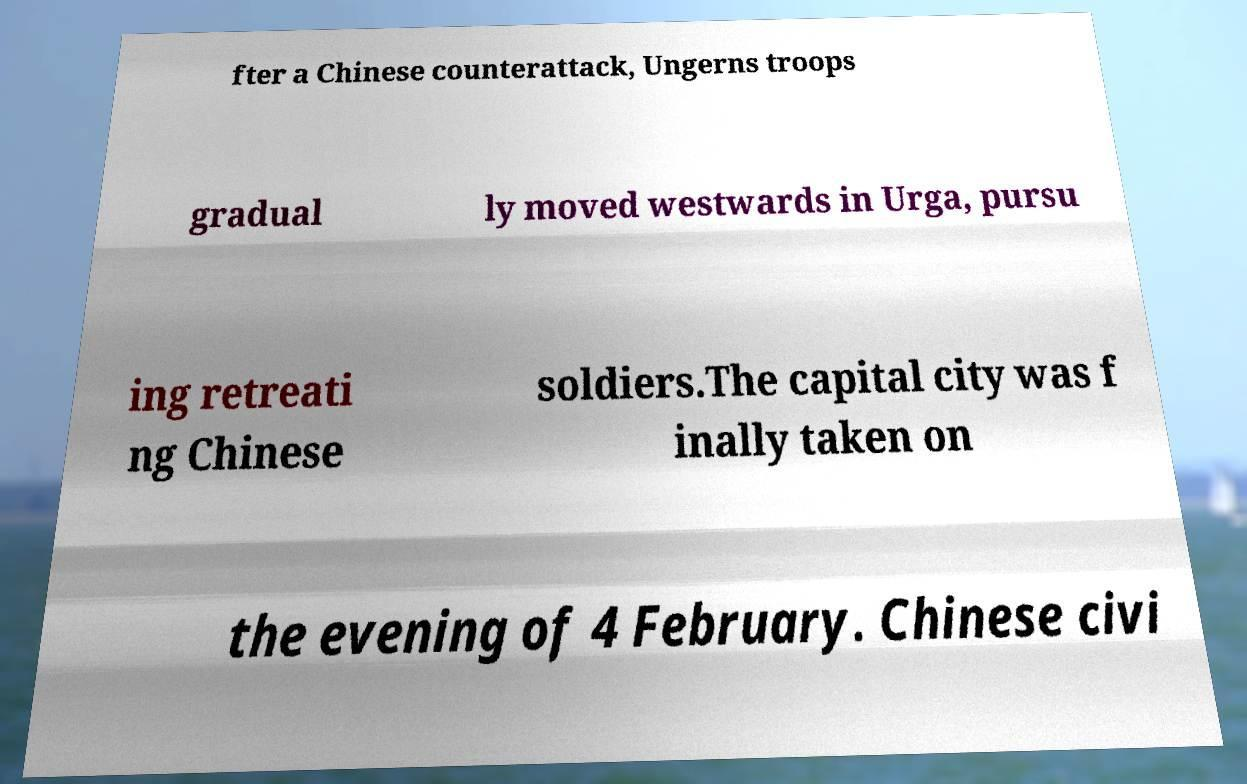Please read and relay the text visible in this image. What does it say? fter a Chinese counterattack, Ungerns troops gradual ly moved westwards in Urga, pursu ing retreati ng Chinese soldiers.The capital city was f inally taken on the evening of 4 February. Chinese civi 